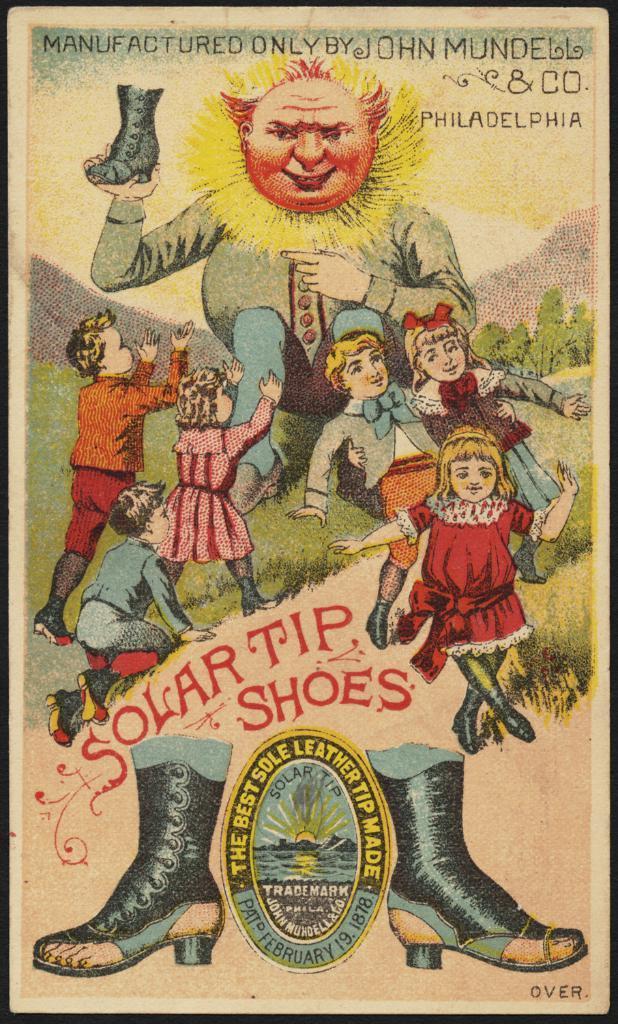In one or two sentences, can you explain what this image depicts? In the middle it is a drawing, there are children on this and trees. 